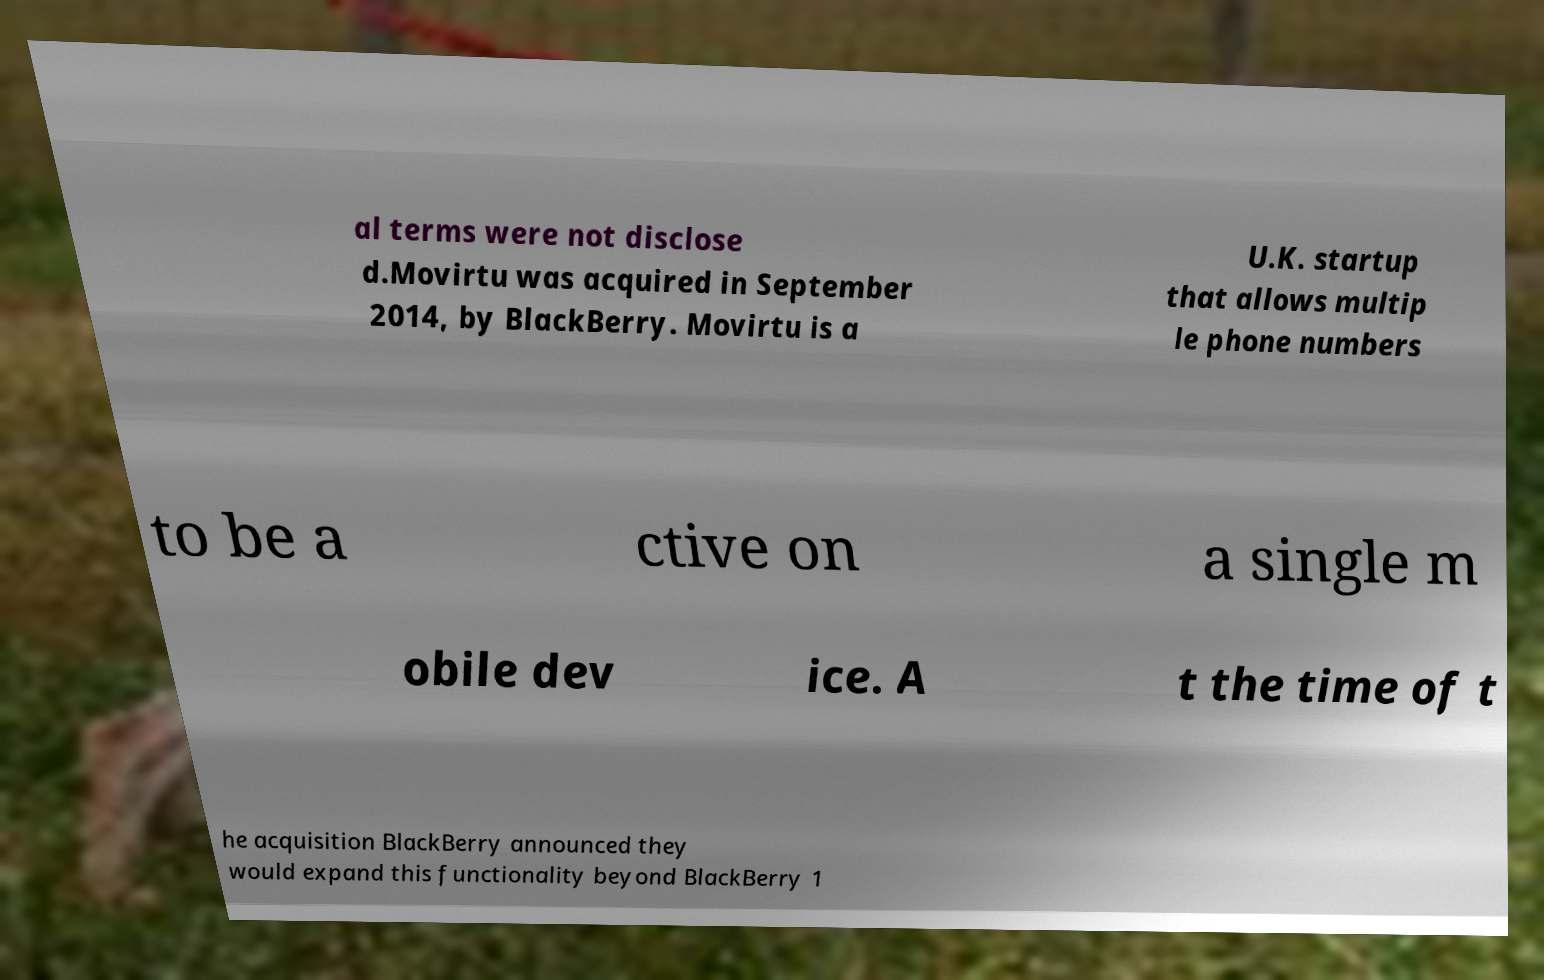Could you assist in decoding the text presented in this image and type it out clearly? al terms were not disclose d.Movirtu was acquired in September 2014, by BlackBerry. Movirtu is a U.K. startup that allows multip le phone numbers to be a ctive on a single m obile dev ice. A t the time of t he acquisition BlackBerry announced they would expand this functionality beyond BlackBerry 1 